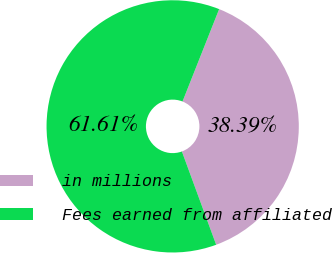<chart> <loc_0><loc_0><loc_500><loc_500><pie_chart><fcel>in millions<fcel>Fees earned from affiliated<nl><fcel>38.39%<fcel>61.61%<nl></chart> 